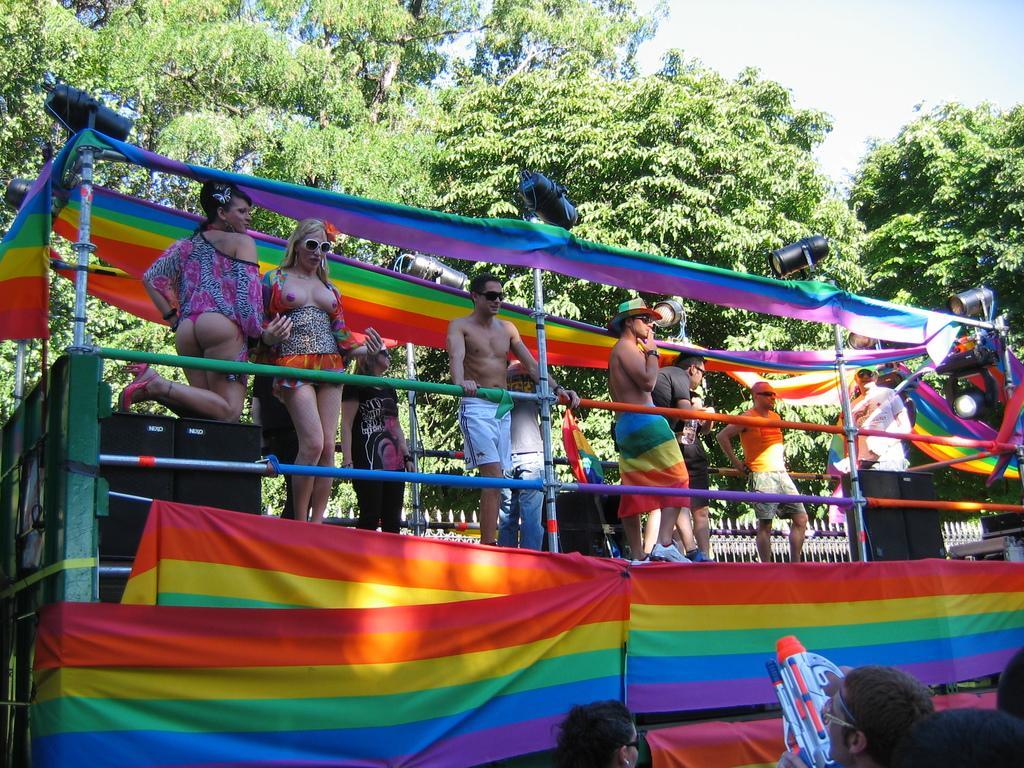Please provide a concise description of this image. Here men and women are standing, these are trees. 